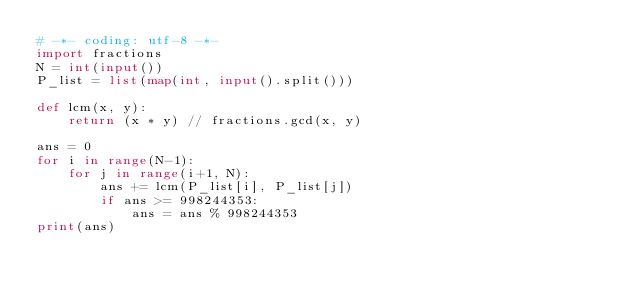<code> <loc_0><loc_0><loc_500><loc_500><_Python_># -*- coding: utf-8 -*-
import fractions
N = int(input())
P_list = list(map(int, input().split()))

def lcm(x, y):
    return (x * y) // fractions.gcd(x, y)

ans = 0
for i in range(N-1):
    for j in range(i+1, N):
        ans += lcm(P_list[i], P_list[j])
        if ans >= 998244353:
            ans = ans % 998244353
print(ans)</code> 